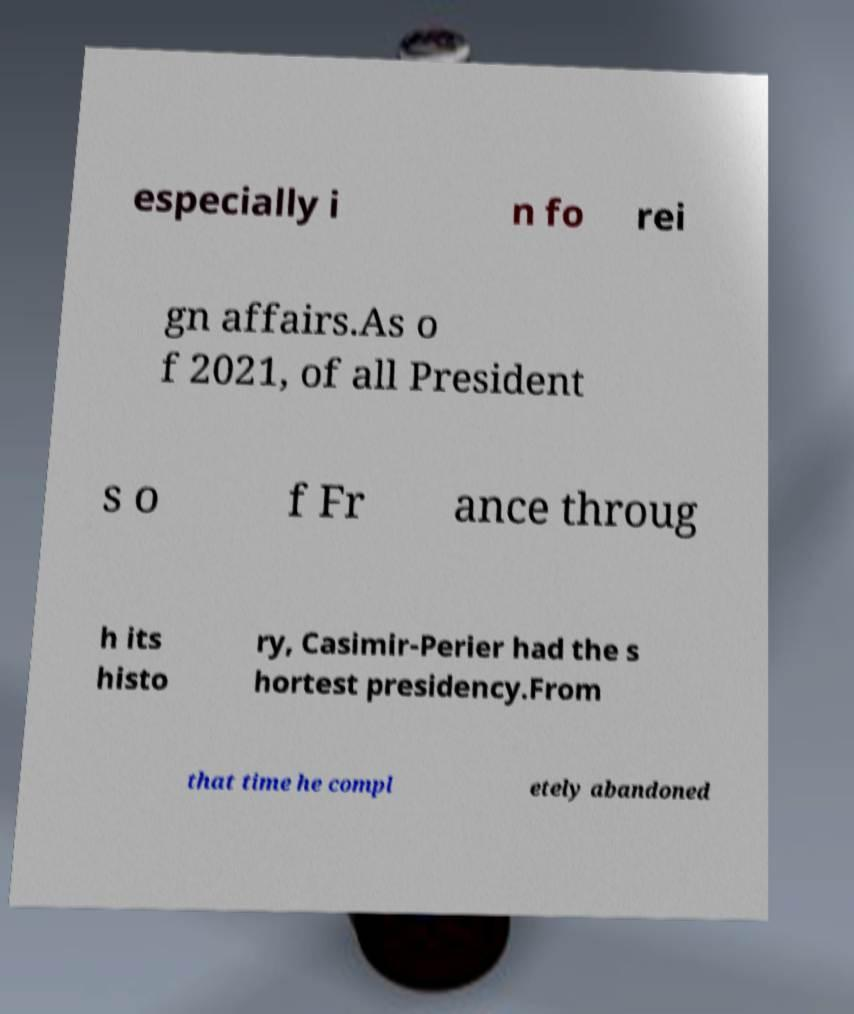Could you assist in decoding the text presented in this image and type it out clearly? especially i n fo rei gn affairs.As o f 2021, of all President s o f Fr ance throug h its histo ry, Casimir-Perier had the s hortest presidency.From that time he compl etely abandoned 